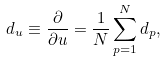Convert formula to latex. <formula><loc_0><loc_0><loc_500><loc_500>d _ { u } \equiv \frac { \partial } { \partial u } = \frac { 1 } { N } \sum _ { p = 1 } ^ { N } d _ { p } ,</formula> 